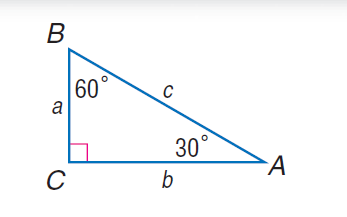Answer the mathemtical geometry problem and directly provide the correct option letter.
Question: If a = 4, find b.
Choices: A: 2 \sqrt { 3 } B: 6 C: 4 \sqrt { 3 } D: 8 C 